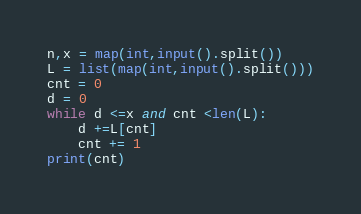<code> <loc_0><loc_0><loc_500><loc_500><_Python_>n,x = map(int,input().split())
L = list(map(int,input().split()))
cnt = 0
d = 0
while d <=x and cnt <len(L):
    d +=L[cnt]
    cnt += 1
print(cnt)
</code> 